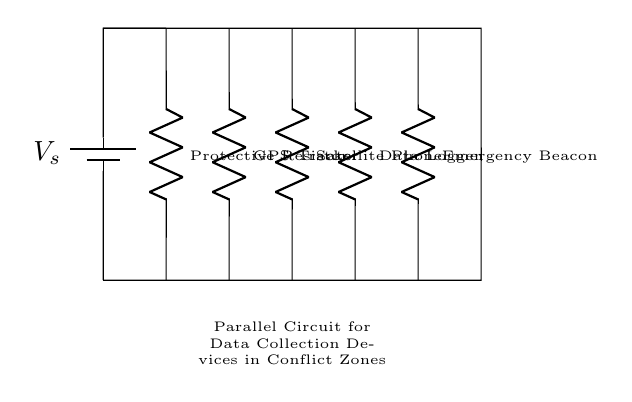What is the source voltage in the circuit? The source voltage is indicated by the label V_s on the battery symbol. It represents the power source for the circuit.
Answer: V_s How many devices are connected in parallel? There are four devices shown in the circuit: GPS Tracker, Satellite Phone, Data Logger, and Emergency Beacon. Each device is connected directly to the voltage source, representing a parallel configuration.
Answer: Four devices What component is labeled as a protective resistor? The protective resistor is identified by the label next to the resistor symbol in the diagram. It serves to limit current through the devices to avoid damage.
Answer: Protective Resistor What type of circuit connection is used for the devices? Each device is connected in a manner that allows each to receive the same voltage from the source, which defines the configuration as parallel.
Answer: Parallel Why are parallel connections used for data collection devices? Parallel connections allow each device to operate independently and receive the same voltage without causing interruptions if one device fails. This is crucial in conflict zones where reliability is important.
Answer: Reliability What role does the battery play in the circuit? The battery serves as the energy source for the whole circuit, providing the necessary voltage to power all connected devices simultaneously.
Answer: Energy source What happens if one device fails in this circuit? If one device fails in a parallel circuit, the other devices will continue to function normally because each is powered directly by the source.
Answer: Other devices continue to function 